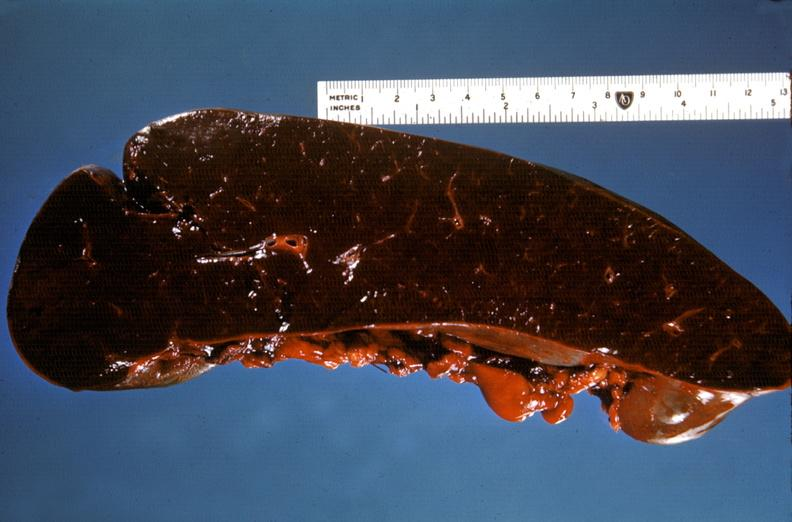does this image show spleen, hypersplenism?
Answer the question using a single word or phrase. Yes 